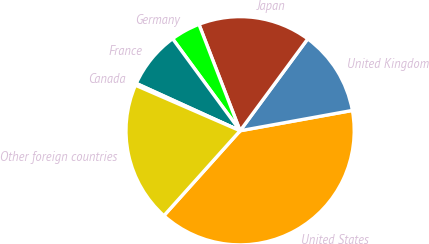<chart> <loc_0><loc_0><loc_500><loc_500><pie_chart><fcel>United States<fcel>United Kingdom<fcel>Japan<fcel>Germany<fcel>France<fcel>Canada<fcel>Other foreign countries<nl><fcel>39.49%<fcel>12.05%<fcel>15.97%<fcel>4.2%<fcel>8.12%<fcel>0.28%<fcel>19.89%<nl></chart> 